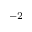Convert formula to latex. <formula><loc_0><loc_0><loc_500><loc_500>^ { - 2 }</formula> 